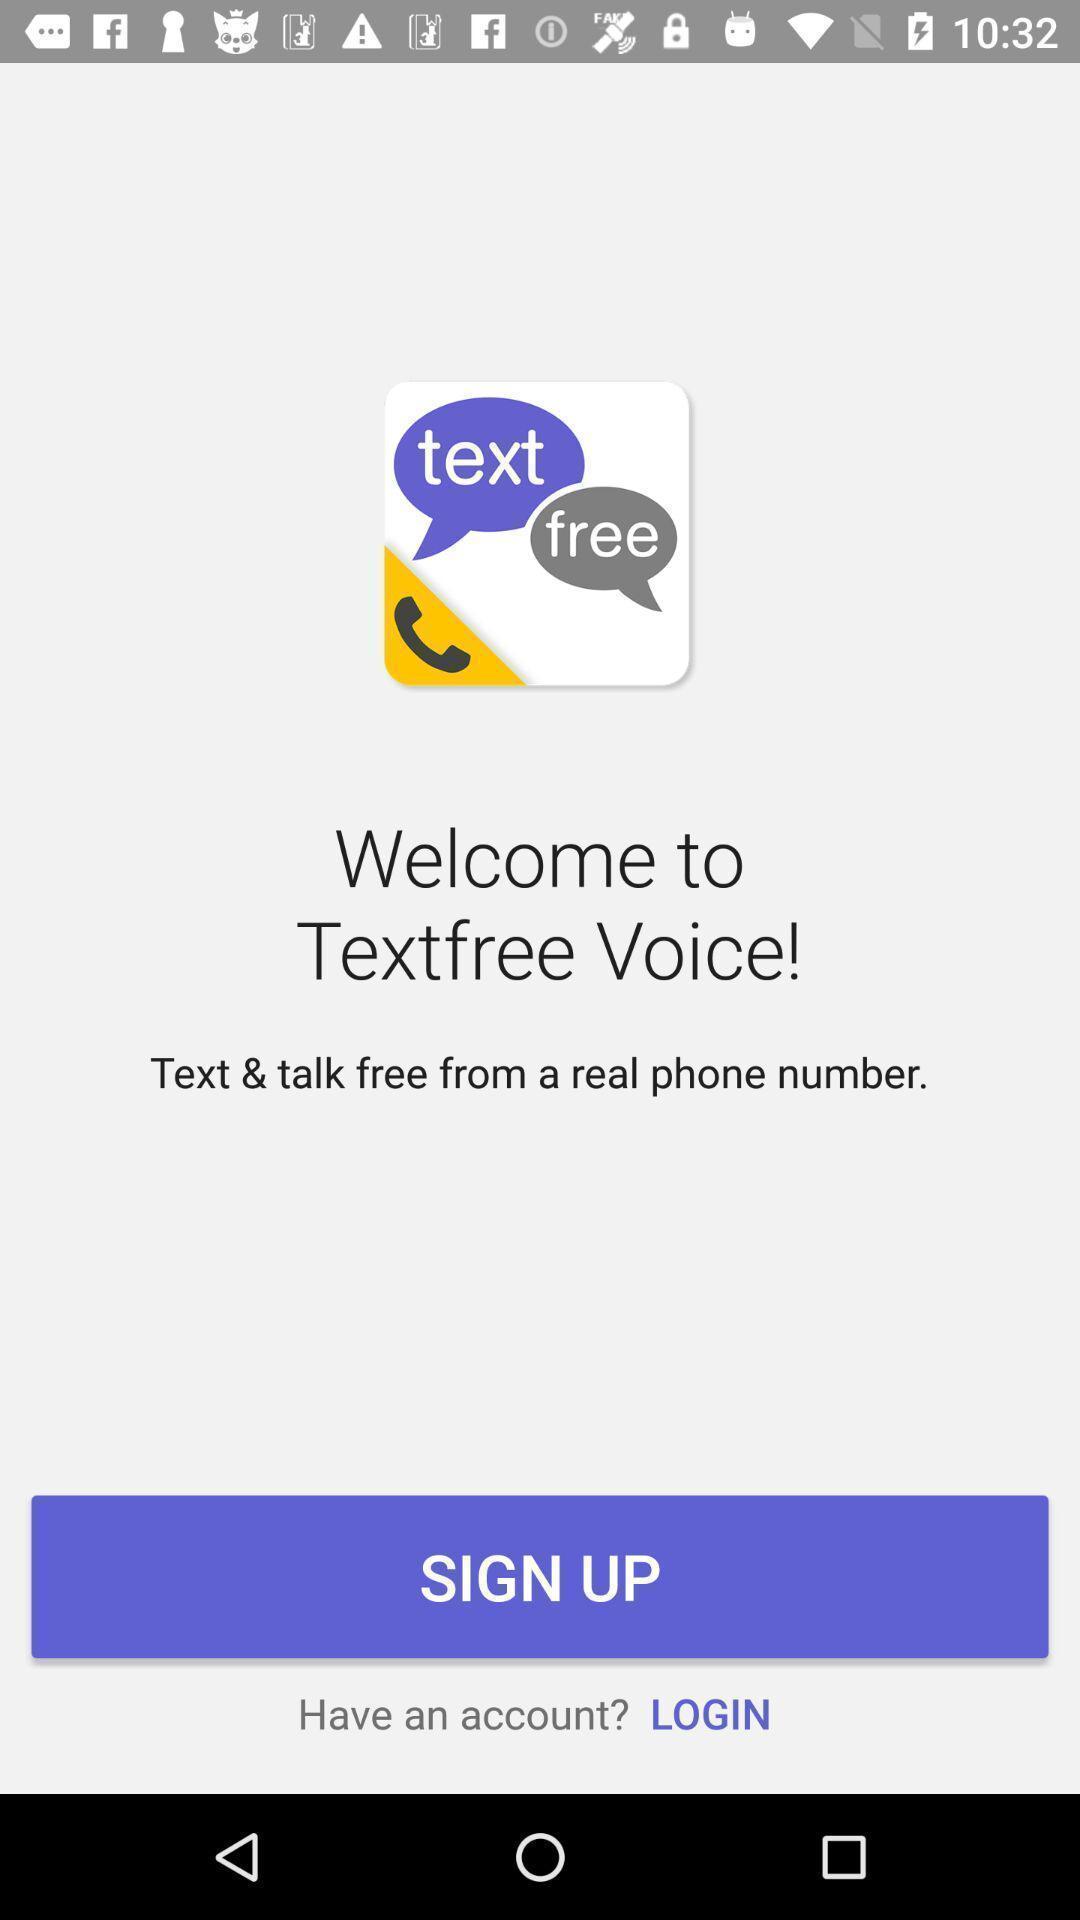Provide a detailed account of this screenshot. Welcome page of a chat app. 